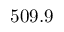Convert formula to latex. <formula><loc_0><loc_0><loc_500><loc_500>5 0 9 . 9</formula> 